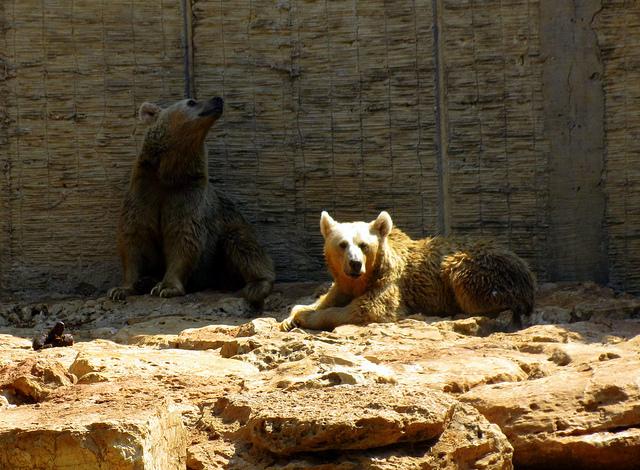What kind of animals are these?
Keep it brief. Bears. What is the color of the bears?
Concise answer only. Brown. Are these bears in a zoo?
Quick response, please. Yes. 